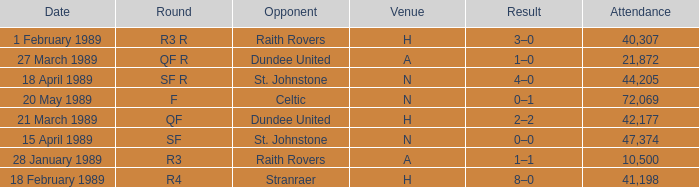What is the specific date for the round in sf? 15 April 1989. 